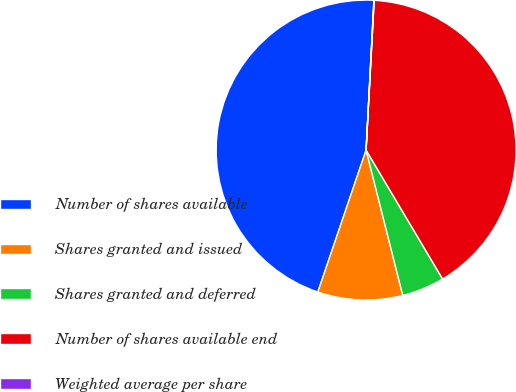Convert chart. <chart><loc_0><loc_0><loc_500><loc_500><pie_chart><fcel>Number of shares available<fcel>Shares granted and issued<fcel>Shares granted and deferred<fcel>Number of shares available end<fcel>Weighted average per share<nl><fcel>45.61%<fcel>9.15%<fcel>4.59%<fcel>40.62%<fcel>0.03%<nl></chart> 